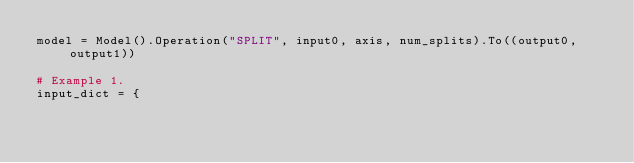<code> <loc_0><loc_0><loc_500><loc_500><_Python_>model = Model().Operation("SPLIT", input0, axis, num_splits).To((output0, output1))

# Example 1.
input_dict = {</code> 